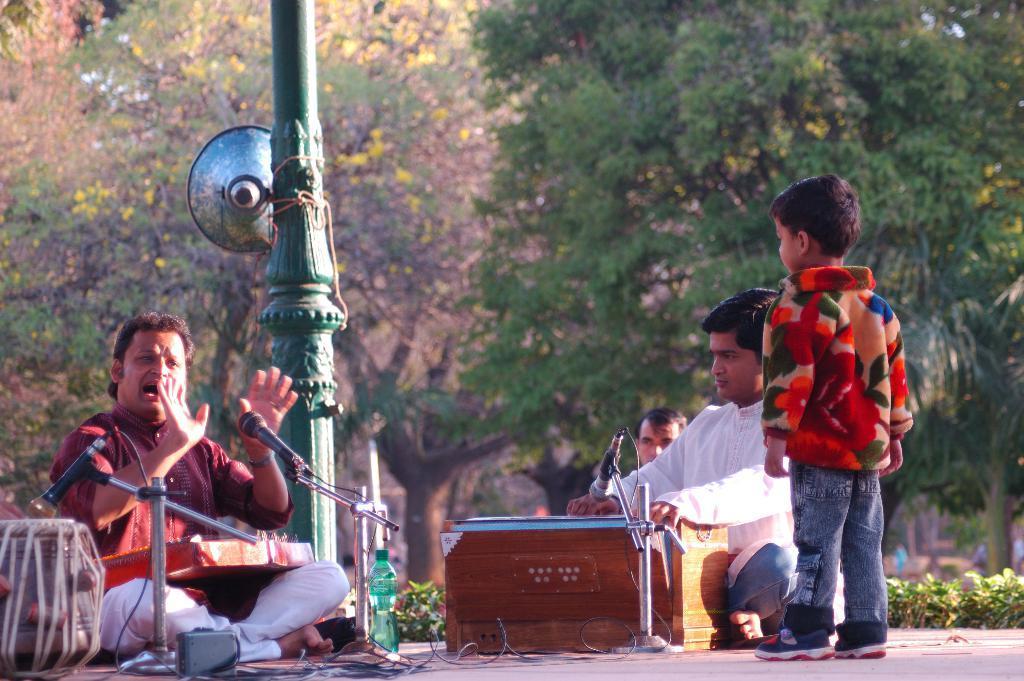In one or two sentences, can you explain what this image depicts? In this image there are two persons sitting on the floor and they are playing a musical instrument, which is in front of them and there are mice and a bottle, beside them there is a child standing, behind them there is another person sitting and there is a pillar with a speaker. In the background there are trees and plants. 